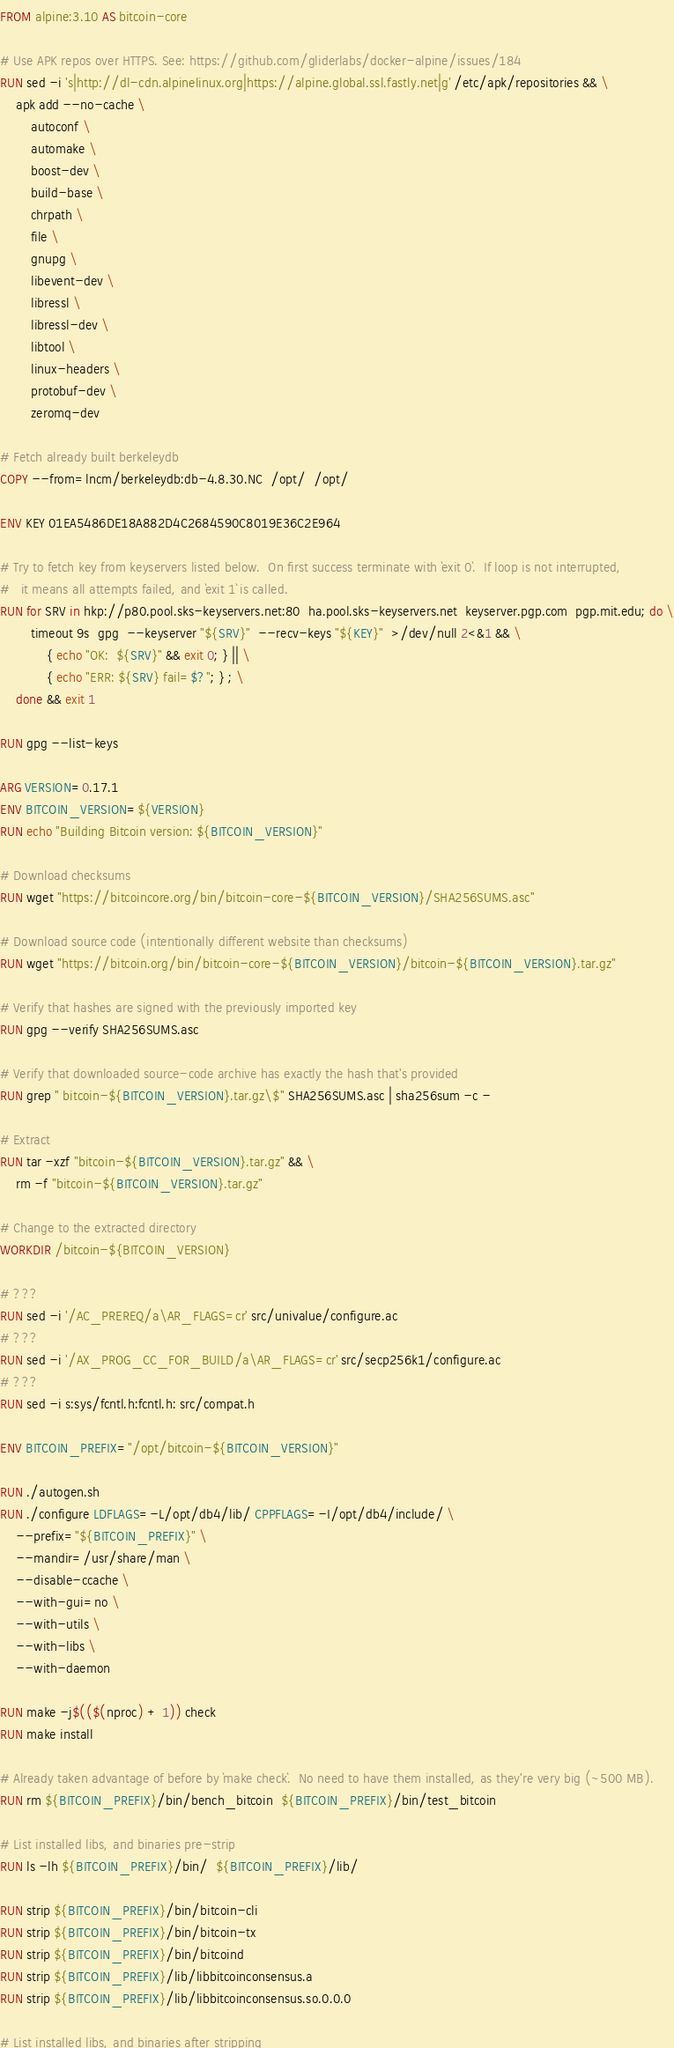<code> <loc_0><loc_0><loc_500><loc_500><_Dockerfile_>FROM alpine:3.10 AS bitcoin-core

# Use APK repos over HTTPS. See: https://github.com/gliderlabs/docker-alpine/issues/184
RUN sed -i 's|http://dl-cdn.alpinelinux.org|https://alpine.global.ssl.fastly.net|g' /etc/apk/repositories && \
    apk add --no-cache \
        autoconf \
        automake \
        boost-dev \
        build-base \
        chrpath \
        file \
        gnupg \
        libevent-dev \
        libressl \
        libressl-dev \
        libtool \
        linux-headers \
        protobuf-dev \
        zeromq-dev

# Fetch already built berkeleydb
COPY --from=lncm/berkeleydb:db-4.8.30.NC  /opt/  /opt/

ENV KEY 01EA5486DE18A882D4C2684590C8019E36C2E964

# Try to fetch key from keyservers listed below.  On first success terminate with `exit 0`.  If loop is not interrupted,
#   it means all attempts failed, and `exit 1` is called.
RUN for SRV in hkp://p80.pool.sks-keyservers.net:80  ha.pool.sks-keyservers.net  keyserver.pgp.com  pgp.mit.edu; do \
        timeout 9s  gpg  --keyserver "${SRV}"  --recv-keys "${KEY}"  >/dev/null 2<&1 && \
            { echo "OK:  ${SRV}" && exit 0; } || \
            { echo "ERR: ${SRV} fail=$?"; } ; \
    done && exit 1

RUN gpg --list-keys

ARG VERSION=0.17.1
ENV BITCOIN_VERSION=${VERSION}
RUN echo "Building Bitcoin version: ${BITCOIN_VERSION}"

# Download checksums
RUN wget "https://bitcoincore.org/bin/bitcoin-core-${BITCOIN_VERSION}/SHA256SUMS.asc"

# Download source code (intentionally different website than checksums)
RUN wget "https://bitcoin.org/bin/bitcoin-core-${BITCOIN_VERSION}/bitcoin-${BITCOIN_VERSION}.tar.gz"

# Verify that hashes are signed with the previously imported key
RUN gpg --verify SHA256SUMS.asc

# Verify that downloaded source-code archive has exactly the hash that's provided
RUN grep " bitcoin-${BITCOIN_VERSION}.tar.gz\$" SHA256SUMS.asc | sha256sum -c -

# Extract
RUN tar -xzf "bitcoin-${BITCOIN_VERSION}.tar.gz" && \
    rm -f "bitcoin-${BITCOIN_VERSION}.tar.gz"

# Change to the extracted directory
WORKDIR /bitcoin-${BITCOIN_VERSION}

# ???
RUN sed -i '/AC_PREREQ/a\AR_FLAGS=cr' src/univalue/configure.ac
# ???
RUN sed -i '/AX_PROG_CC_FOR_BUILD/a\AR_FLAGS=cr' src/secp256k1/configure.ac
# ???
RUN sed -i s:sys/fcntl.h:fcntl.h: src/compat.h

ENV BITCOIN_PREFIX="/opt/bitcoin-${BITCOIN_VERSION}"

RUN ./autogen.sh
RUN ./configure LDFLAGS=-L/opt/db4/lib/ CPPFLAGS=-I/opt/db4/include/ \
    --prefix="${BITCOIN_PREFIX}" \
    --mandir=/usr/share/man \
    --disable-ccache \
    --with-gui=no \
    --with-utils \
    --with-libs \
    --with-daemon

RUN make -j$(($(nproc) + 1)) check
RUN make install

# Already taken advantage of before by `make check`.  No need to have them installed, as they're very big (~500 MB).
RUN rm ${BITCOIN_PREFIX}/bin/bench_bitcoin  ${BITCOIN_PREFIX}/bin/test_bitcoin

# List installed libs, and binaries pre-strip
RUN ls -lh ${BITCOIN_PREFIX}/bin/  ${BITCOIN_PREFIX}/lib/

RUN strip ${BITCOIN_PREFIX}/bin/bitcoin-cli
RUN strip ${BITCOIN_PREFIX}/bin/bitcoin-tx
RUN strip ${BITCOIN_PREFIX}/bin/bitcoind
RUN strip ${BITCOIN_PREFIX}/lib/libbitcoinconsensus.a
RUN strip ${BITCOIN_PREFIX}/lib/libbitcoinconsensus.so.0.0.0

# List installed libs, and binaries after stripping</code> 